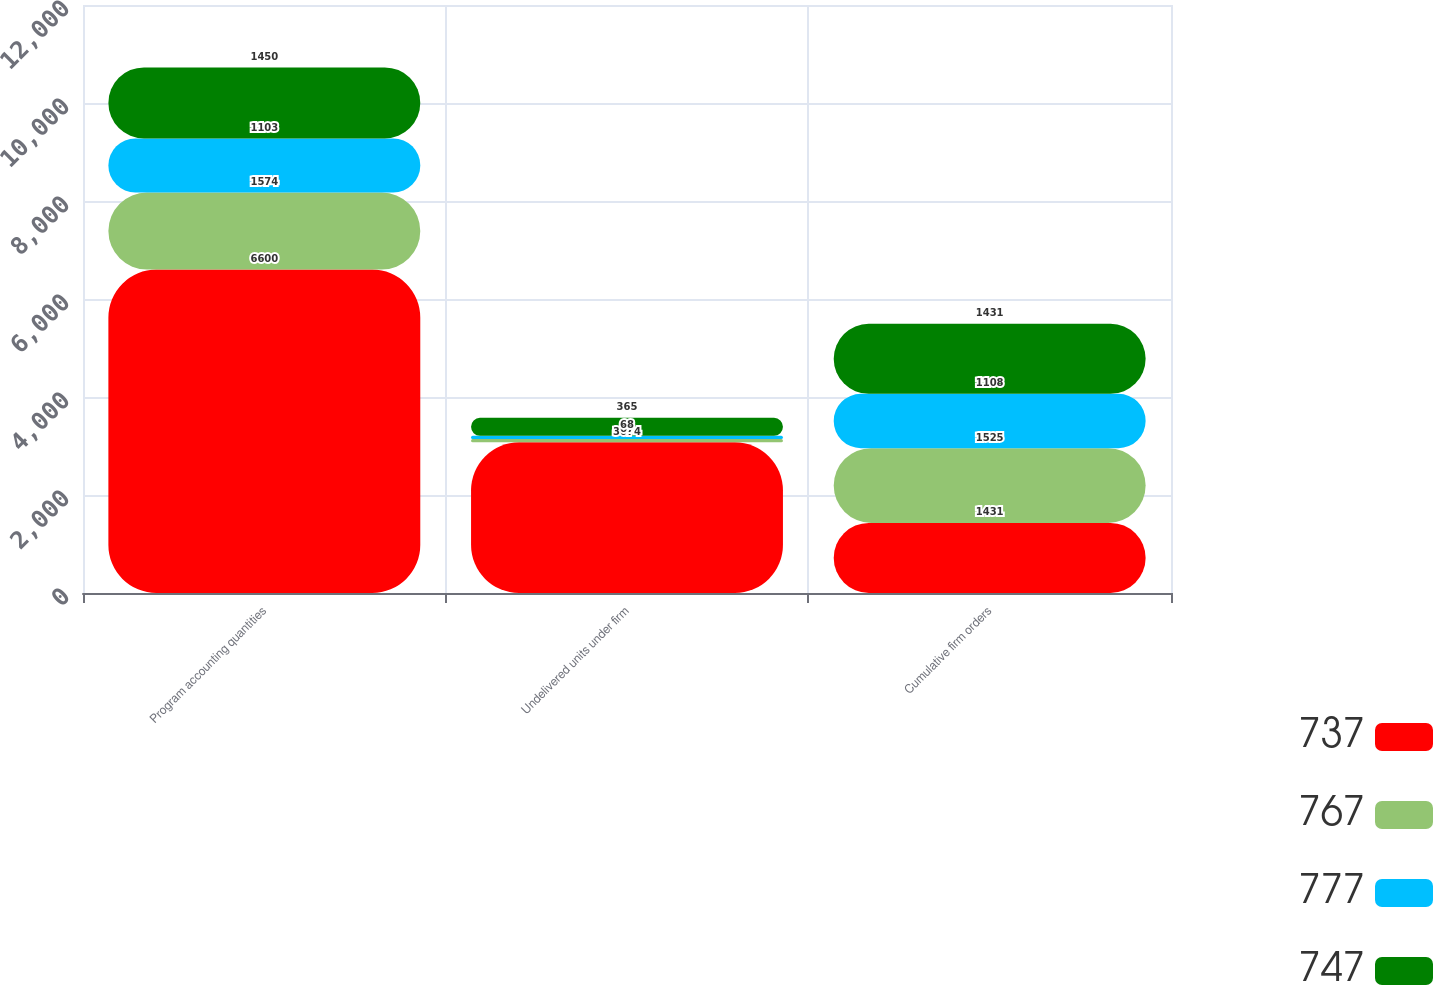Convert chart. <chart><loc_0><loc_0><loc_500><loc_500><stacked_bar_chart><ecel><fcel>Program accounting quantities<fcel>Undelivered units under firm<fcel>Cumulative firm orders<nl><fcel>737<fcel>6600<fcel>3074<fcel>1431<nl><fcel>767<fcel>1574<fcel>67<fcel>1525<nl><fcel>777<fcel>1103<fcel>68<fcel>1108<nl><fcel>747<fcel>1450<fcel>365<fcel>1431<nl></chart> 